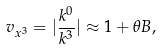<formula> <loc_0><loc_0><loc_500><loc_500>v _ { x ^ { 3 } } = | \frac { k ^ { 0 } } { k ^ { 3 } } | \approx 1 + \theta B ,</formula> 